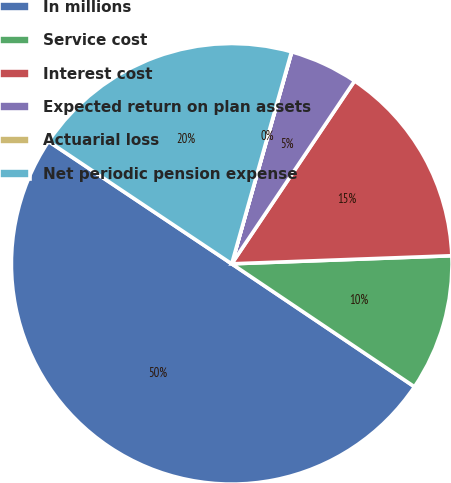<chart> <loc_0><loc_0><loc_500><loc_500><pie_chart><fcel>In millions<fcel>Service cost<fcel>Interest cost<fcel>Expected return on plan assets<fcel>Actuarial loss<fcel>Net periodic pension expense<nl><fcel>49.95%<fcel>10.01%<fcel>15.0%<fcel>5.02%<fcel>0.02%<fcel>20.0%<nl></chart> 